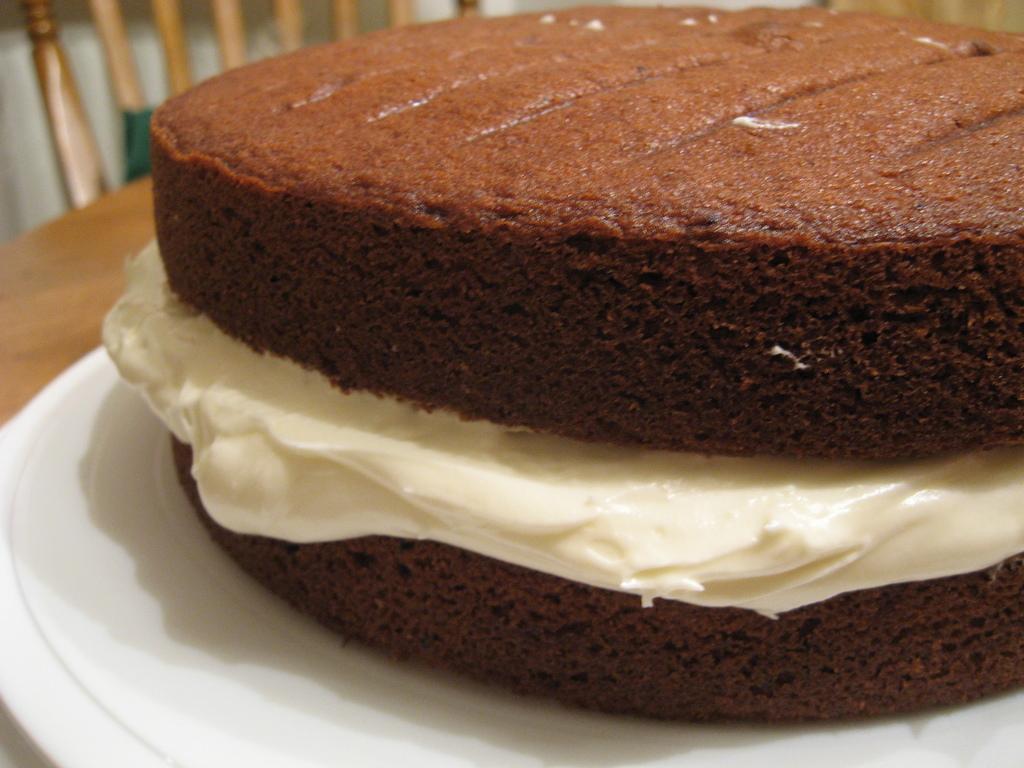Could you give a brief overview of what you see in this image? In the picture I can see a chocolate cake on the plate and the plate is kept on the table. It is looking like a wooden chair on the top left side of the picture. 